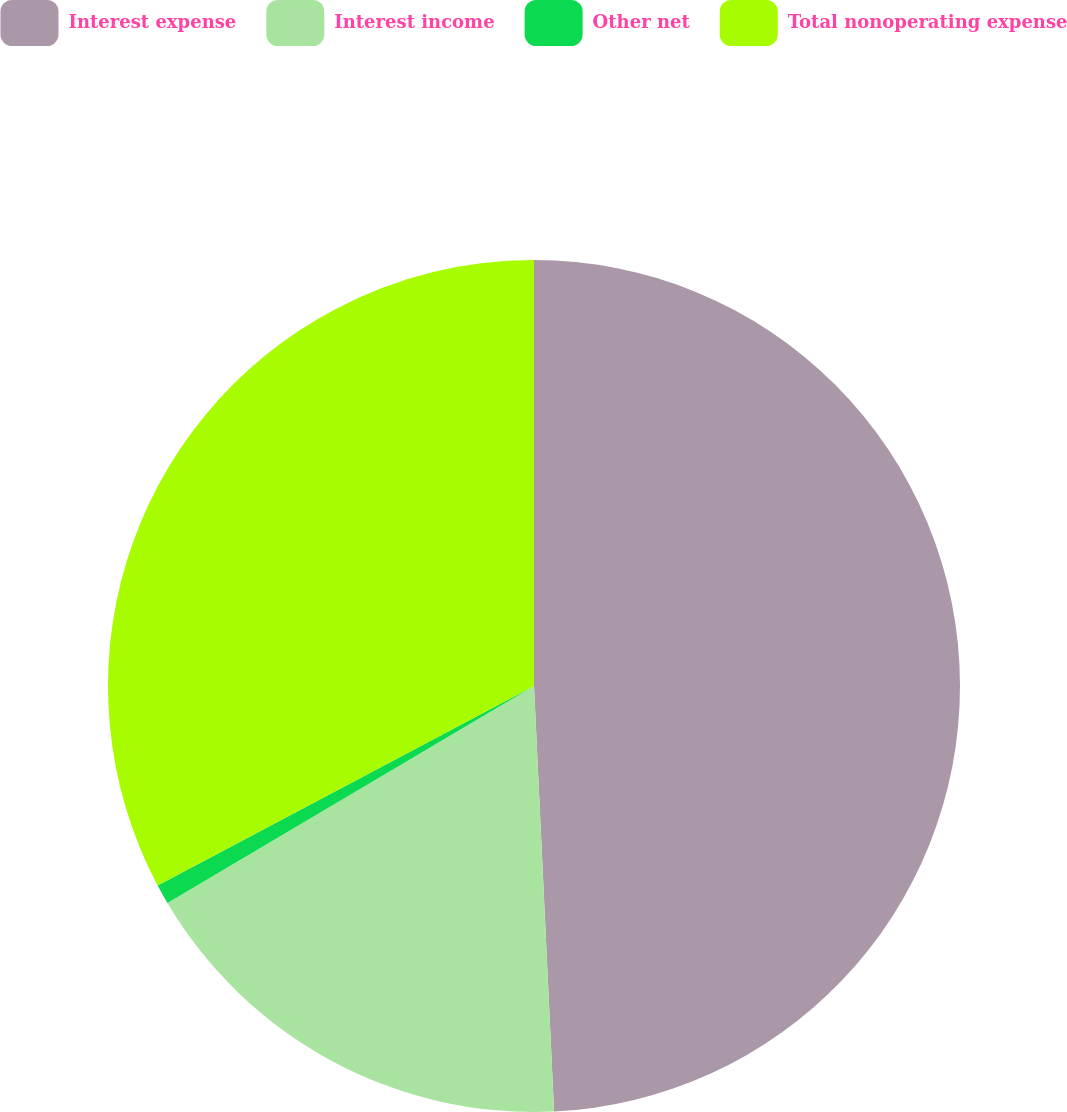Convert chart. <chart><loc_0><loc_0><loc_500><loc_500><pie_chart><fcel>Interest expense<fcel>Interest income<fcel>Other net<fcel>Total nonoperating expense<nl><fcel>49.25%<fcel>17.24%<fcel>0.75%<fcel>32.76%<nl></chart> 